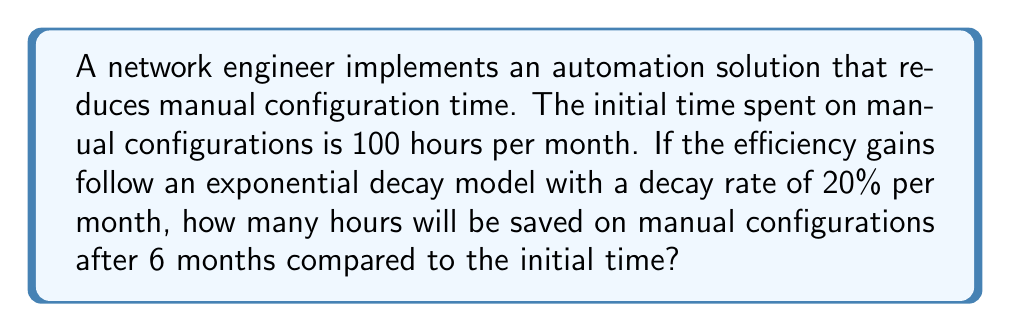Show me your answer to this math problem. Let's approach this step-by-step:

1) The exponential decay model is given by the formula:
   $$A(t) = A_0 \cdot e^{-rt}$$
   Where:
   $A(t)$ is the amount at time $t$
   $A_0$ is the initial amount
   $r$ is the decay rate
   $t$ is the time

2) In this case:
   $A_0 = 100$ hours
   $r = 0.20$ (20% expressed as a decimal)
   $t = 6$ months

3) Let's calculate the time spent on manual configurations after 6 months:
   $$A(6) = 100 \cdot e^{-0.20 \cdot 6}$$

4) Simplify:
   $$A(6) = 100 \cdot e^{-1.2}$$

5) Calculate (rounded to two decimal places):
   $$A(6) \approx 30.12 \text{ hours}$$

6) To find the time saved, subtract this from the initial time:
   $$\text{Time saved} = 100 - 30.12 = 69.88 \text{ hours}$$

Therefore, after 6 months, approximately 69.88 hours will be saved compared to the initial time.
Answer: $69.88$ hours 